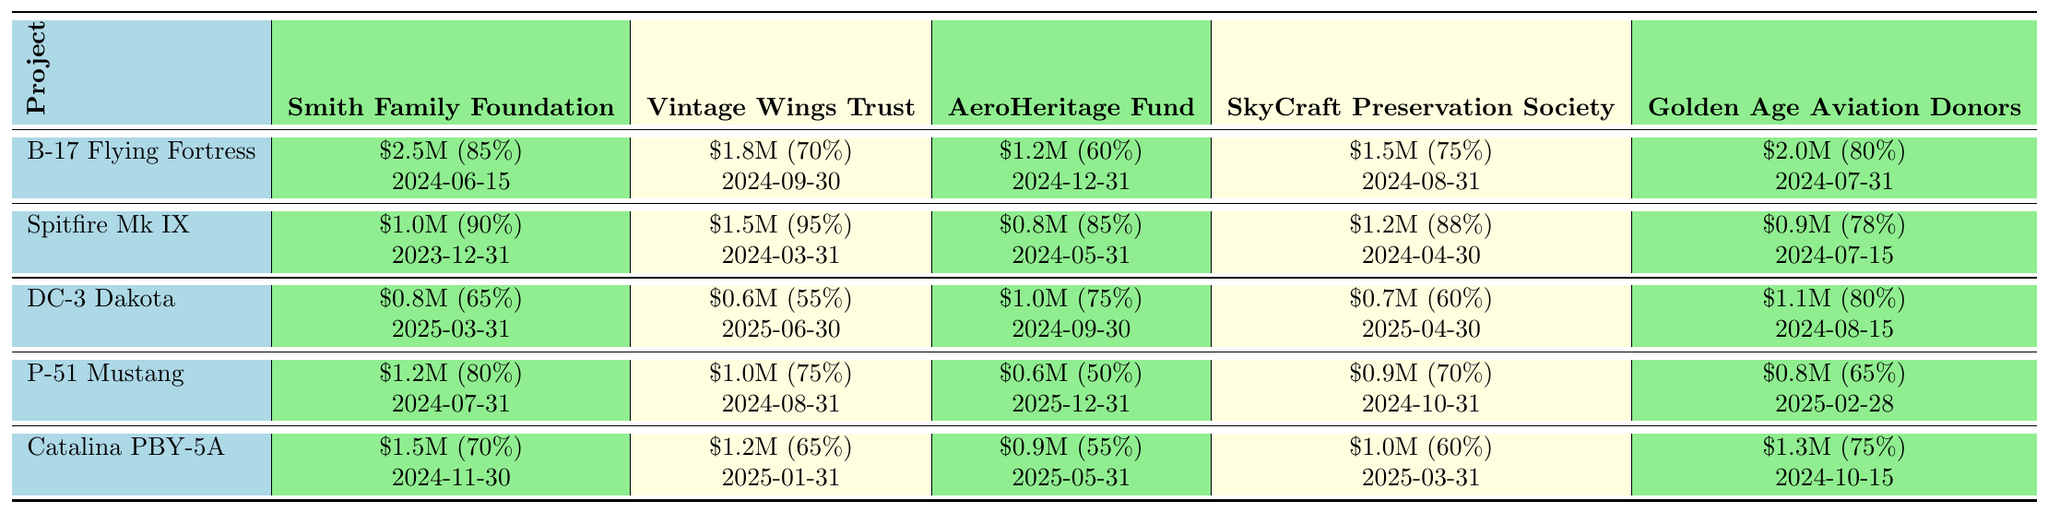What is the total funding allocation for the B-17 Flying Fortress Restoration project? The total funding allocation can be found by adding the allocations from each funding source for the B-17 project: $2.5M + $1.8M + $1.2M + $1.5M + $2.0M = $10M.
Answer: $10M Which project has the highest completion percentage? The completion percentages for all projects are compared, and the highest percentage is 90% for the Spitfire Mk IX Rebuild.
Answer: Spitfire Mk IX Rebuild What is the estimated completion date for the DC-3 Dakota Overhaul project? The estimated completion date for the DC-3 Dakota Overhaul project is displayed directly in the table, which shows 2025-03-31 for that project.
Answer: 2025-03-31 How much funding does the SkyCraft Preservation Society allocate to the B-17 Flying Fortress Restoration? Referring to the table, the SkyCraft Preservation Society allocates $1.5M to the B-17 Flying Fortress Restoration project.
Answer: $1.5M What is the average funding received by the Catalina PBY-5A Refurbishment project? The funding allocations for the Catalina project are $1.5M, $1.2M, $0.9M, $1.0M, and $1.3M. Adding these gives $6M, and dividing by 5 projects yields an average funding of $1.2M.
Answer: $1.2M Is the completion percentage for the P-51 Mustang Renovation greater than 70%? By reviewing the completion percentages, the highest percentage for the P-51 Mustang is 80%, which is greater than 70%.
Answer: Yes Which funding source contributed the least to the Spitfire Mk IX Rebuild project? The allocations for the Spitfire Mk IX Rebuild from each funding source are analyzed: $1.0M, $1.5M, $0.8M, $1.2M, and $0.9M. The least contribution is $0.8M from the AeroHeritage Fund.
Answer: AeroHeritage Fund What is the difference in funding between the highest and lowest funding sources for the DC-3 Dakota Overhaul? The highest funding for DC-3 from AeroHeritage Fund is $1.0M and the lowest from Vintage Wings Trust is $0.6M. The difference is $1.0M - $0.6M = $0.4M.
Answer: $0.4M What proportion of funding does the Smith Family Foundation contribute to the P-51 Mustang Renovation as compared to its total project cost? The Smith Family Foundation contributes $1.2M to the P-51 project, and the total cost is $1.2M + $1.0M + $0.6M + $0.9M + $0.8M = $4.5M. The proportion is $1.2M / $4.5M = 0.267 or 26.7%.
Answer: 26.7% Which project shows a decrease in completion percentage when compared to the Catalina PBY-5A Refurbishment? The Catalina PBY-5A has completion percentages of 70%, 65%, 55%, 60%, and 75%; the projects needing to be compared are those with completion percentages lower than 60% like DC-3 Dakota (65% maximum) and P-51 Mustang (50% maximum).
Answer: DC-3 Dakota & P-51 Mustang 